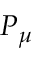<formula> <loc_0><loc_0><loc_500><loc_500>P _ { \mu }</formula> 